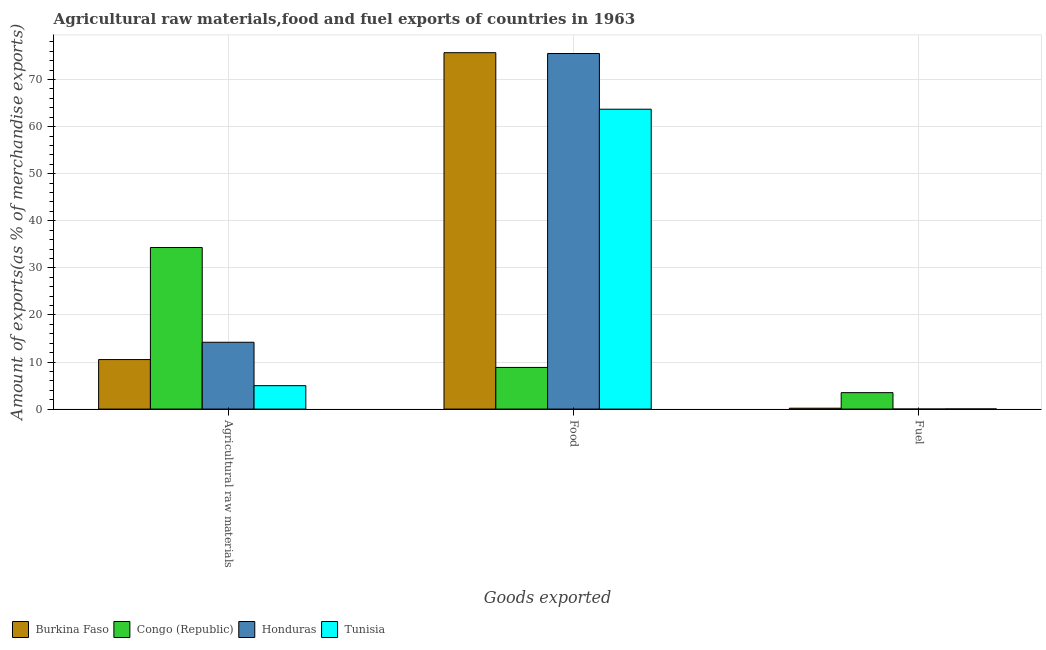How many different coloured bars are there?
Offer a terse response. 4. Are the number of bars on each tick of the X-axis equal?
Make the answer very short. Yes. How many bars are there on the 3rd tick from the right?
Provide a short and direct response. 4. What is the label of the 2nd group of bars from the left?
Your response must be concise. Food. What is the percentage of fuel exports in Congo (Republic)?
Offer a terse response. 3.49. Across all countries, what is the maximum percentage of food exports?
Make the answer very short. 75.71. Across all countries, what is the minimum percentage of fuel exports?
Keep it short and to the point. 1.2206406625286e-6. In which country was the percentage of fuel exports maximum?
Your answer should be compact. Congo (Republic). In which country was the percentage of fuel exports minimum?
Your answer should be very brief. Honduras. What is the total percentage of food exports in the graph?
Your answer should be very brief. 223.8. What is the difference between the percentage of food exports in Honduras and that in Congo (Republic)?
Ensure brevity in your answer.  66.69. What is the difference between the percentage of food exports in Honduras and the percentage of raw materials exports in Congo (Republic)?
Provide a succinct answer. 41.22. What is the average percentage of raw materials exports per country?
Provide a succinct answer. 16. What is the difference between the percentage of raw materials exports and percentage of food exports in Congo (Republic)?
Keep it short and to the point. 25.47. What is the ratio of the percentage of raw materials exports in Congo (Republic) to that in Tunisia?
Make the answer very short. 6.9. Is the percentage of raw materials exports in Congo (Republic) less than that in Honduras?
Your answer should be compact. No. Is the difference between the percentage of food exports in Honduras and Burkina Faso greater than the difference between the percentage of fuel exports in Honduras and Burkina Faso?
Give a very brief answer. Yes. What is the difference between the highest and the second highest percentage of fuel exports?
Offer a very short reply. 3.31. What is the difference between the highest and the lowest percentage of raw materials exports?
Ensure brevity in your answer.  29.35. In how many countries, is the percentage of raw materials exports greater than the average percentage of raw materials exports taken over all countries?
Your response must be concise. 1. What does the 1st bar from the left in Food represents?
Ensure brevity in your answer.  Burkina Faso. What does the 2nd bar from the right in Agricultural raw materials represents?
Make the answer very short. Honduras. Is it the case that in every country, the sum of the percentage of raw materials exports and percentage of food exports is greater than the percentage of fuel exports?
Provide a short and direct response. Yes. How many bars are there?
Offer a terse response. 12. What is the difference between two consecutive major ticks on the Y-axis?
Your answer should be very brief. 10. Are the values on the major ticks of Y-axis written in scientific E-notation?
Your response must be concise. No. Does the graph contain any zero values?
Your answer should be very brief. No. Does the graph contain grids?
Ensure brevity in your answer.  Yes. Where does the legend appear in the graph?
Make the answer very short. Bottom left. What is the title of the graph?
Provide a succinct answer. Agricultural raw materials,food and fuel exports of countries in 1963. What is the label or title of the X-axis?
Your answer should be compact. Goods exported. What is the label or title of the Y-axis?
Give a very brief answer. Amount of exports(as % of merchandise exports). What is the Amount of exports(as % of merchandise exports) in Burkina Faso in Agricultural raw materials?
Ensure brevity in your answer.  10.52. What is the Amount of exports(as % of merchandise exports) of Congo (Republic) in Agricultural raw materials?
Give a very brief answer. 34.32. What is the Amount of exports(as % of merchandise exports) of Honduras in Agricultural raw materials?
Make the answer very short. 14.2. What is the Amount of exports(as % of merchandise exports) in Tunisia in Agricultural raw materials?
Provide a short and direct response. 4.98. What is the Amount of exports(as % of merchandise exports) of Burkina Faso in Food?
Keep it short and to the point. 75.71. What is the Amount of exports(as % of merchandise exports) in Congo (Republic) in Food?
Give a very brief answer. 8.85. What is the Amount of exports(as % of merchandise exports) in Honduras in Food?
Keep it short and to the point. 75.54. What is the Amount of exports(as % of merchandise exports) of Tunisia in Food?
Make the answer very short. 63.7. What is the Amount of exports(as % of merchandise exports) in Burkina Faso in Fuel?
Keep it short and to the point. 0.19. What is the Amount of exports(as % of merchandise exports) of Congo (Republic) in Fuel?
Your answer should be compact. 3.49. What is the Amount of exports(as % of merchandise exports) of Honduras in Fuel?
Offer a terse response. 1.2206406625286e-6. What is the Amount of exports(as % of merchandise exports) in Tunisia in Fuel?
Your answer should be compact. 0.03. Across all Goods exported, what is the maximum Amount of exports(as % of merchandise exports) in Burkina Faso?
Your response must be concise. 75.71. Across all Goods exported, what is the maximum Amount of exports(as % of merchandise exports) of Congo (Republic)?
Your answer should be compact. 34.32. Across all Goods exported, what is the maximum Amount of exports(as % of merchandise exports) in Honduras?
Provide a short and direct response. 75.54. Across all Goods exported, what is the maximum Amount of exports(as % of merchandise exports) in Tunisia?
Offer a terse response. 63.7. Across all Goods exported, what is the minimum Amount of exports(as % of merchandise exports) in Burkina Faso?
Your answer should be compact. 0.19. Across all Goods exported, what is the minimum Amount of exports(as % of merchandise exports) in Congo (Republic)?
Make the answer very short. 3.49. Across all Goods exported, what is the minimum Amount of exports(as % of merchandise exports) of Honduras?
Your answer should be compact. 1.2206406625286e-6. Across all Goods exported, what is the minimum Amount of exports(as % of merchandise exports) in Tunisia?
Provide a short and direct response. 0.03. What is the total Amount of exports(as % of merchandise exports) of Burkina Faso in the graph?
Your response must be concise. 86.41. What is the total Amount of exports(as % of merchandise exports) of Congo (Republic) in the graph?
Provide a short and direct response. 46.66. What is the total Amount of exports(as % of merchandise exports) of Honduras in the graph?
Ensure brevity in your answer.  89.74. What is the total Amount of exports(as % of merchandise exports) in Tunisia in the graph?
Your response must be concise. 68.71. What is the difference between the Amount of exports(as % of merchandise exports) of Burkina Faso in Agricultural raw materials and that in Food?
Your answer should be very brief. -65.2. What is the difference between the Amount of exports(as % of merchandise exports) of Congo (Republic) in Agricultural raw materials and that in Food?
Make the answer very short. 25.47. What is the difference between the Amount of exports(as % of merchandise exports) of Honduras in Agricultural raw materials and that in Food?
Your answer should be compact. -61.34. What is the difference between the Amount of exports(as % of merchandise exports) of Tunisia in Agricultural raw materials and that in Food?
Offer a terse response. -58.73. What is the difference between the Amount of exports(as % of merchandise exports) of Burkina Faso in Agricultural raw materials and that in Fuel?
Provide a short and direct response. 10.33. What is the difference between the Amount of exports(as % of merchandise exports) of Congo (Republic) in Agricultural raw materials and that in Fuel?
Ensure brevity in your answer.  30.83. What is the difference between the Amount of exports(as % of merchandise exports) in Honduras in Agricultural raw materials and that in Fuel?
Offer a terse response. 14.2. What is the difference between the Amount of exports(as % of merchandise exports) of Tunisia in Agricultural raw materials and that in Fuel?
Offer a very short reply. 4.95. What is the difference between the Amount of exports(as % of merchandise exports) of Burkina Faso in Food and that in Fuel?
Ensure brevity in your answer.  75.53. What is the difference between the Amount of exports(as % of merchandise exports) in Congo (Republic) in Food and that in Fuel?
Keep it short and to the point. 5.36. What is the difference between the Amount of exports(as % of merchandise exports) of Honduras in Food and that in Fuel?
Provide a succinct answer. 75.54. What is the difference between the Amount of exports(as % of merchandise exports) in Tunisia in Food and that in Fuel?
Your response must be concise. 63.68. What is the difference between the Amount of exports(as % of merchandise exports) in Burkina Faso in Agricultural raw materials and the Amount of exports(as % of merchandise exports) in Congo (Republic) in Food?
Offer a very short reply. 1.67. What is the difference between the Amount of exports(as % of merchandise exports) in Burkina Faso in Agricultural raw materials and the Amount of exports(as % of merchandise exports) in Honduras in Food?
Give a very brief answer. -65.02. What is the difference between the Amount of exports(as % of merchandise exports) of Burkina Faso in Agricultural raw materials and the Amount of exports(as % of merchandise exports) of Tunisia in Food?
Give a very brief answer. -53.19. What is the difference between the Amount of exports(as % of merchandise exports) in Congo (Republic) in Agricultural raw materials and the Amount of exports(as % of merchandise exports) in Honduras in Food?
Your answer should be compact. -41.22. What is the difference between the Amount of exports(as % of merchandise exports) of Congo (Republic) in Agricultural raw materials and the Amount of exports(as % of merchandise exports) of Tunisia in Food?
Offer a very short reply. -29.38. What is the difference between the Amount of exports(as % of merchandise exports) of Honduras in Agricultural raw materials and the Amount of exports(as % of merchandise exports) of Tunisia in Food?
Your response must be concise. -49.51. What is the difference between the Amount of exports(as % of merchandise exports) of Burkina Faso in Agricultural raw materials and the Amount of exports(as % of merchandise exports) of Congo (Republic) in Fuel?
Provide a succinct answer. 7.03. What is the difference between the Amount of exports(as % of merchandise exports) in Burkina Faso in Agricultural raw materials and the Amount of exports(as % of merchandise exports) in Honduras in Fuel?
Offer a very short reply. 10.52. What is the difference between the Amount of exports(as % of merchandise exports) of Burkina Faso in Agricultural raw materials and the Amount of exports(as % of merchandise exports) of Tunisia in Fuel?
Offer a terse response. 10.49. What is the difference between the Amount of exports(as % of merchandise exports) of Congo (Republic) in Agricultural raw materials and the Amount of exports(as % of merchandise exports) of Honduras in Fuel?
Your response must be concise. 34.32. What is the difference between the Amount of exports(as % of merchandise exports) of Congo (Republic) in Agricultural raw materials and the Amount of exports(as % of merchandise exports) of Tunisia in Fuel?
Your answer should be very brief. 34.29. What is the difference between the Amount of exports(as % of merchandise exports) of Honduras in Agricultural raw materials and the Amount of exports(as % of merchandise exports) of Tunisia in Fuel?
Your response must be concise. 14.17. What is the difference between the Amount of exports(as % of merchandise exports) in Burkina Faso in Food and the Amount of exports(as % of merchandise exports) in Congo (Republic) in Fuel?
Make the answer very short. 72.22. What is the difference between the Amount of exports(as % of merchandise exports) of Burkina Faso in Food and the Amount of exports(as % of merchandise exports) of Honduras in Fuel?
Offer a very short reply. 75.71. What is the difference between the Amount of exports(as % of merchandise exports) of Burkina Faso in Food and the Amount of exports(as % of merchandise exports) of Tunisia in Fuel?
Your response must be concise. 75.68. What is the difference between the Amount of exports(as % of merchandise exports) in Congo (Republic) in Food and the Amount of exports(as % of merchandise exports) in Honduras in Fuel?
Make the answer very short. 8.85. What is the difference between the Amount of exports(as % of merchandise exports) of Congo (Republic) in Food and the Amount of exports(as % of merchandise exports) of Tunisia in Fuel?
Give a very brief answer. 8.82. What is the difference between the Amount of exports(as % of merchandise exports) of Honduras in Food and the Amount of exports(as % of merchandise exports) of Tunisia in Fuel?
Ensure brevity in your answer.  75.51. What is the average Amount of exports(as % of merchandise exports) of Burkina Faso per Goods exported?
Provide a short and direct response. 28.8. What is the average Amount of exports(as % of merchandise exports) in Congo (Republic) per Goods exported?
Give a very brief answer. 15.55. What is the average Amount of exports(as % of merchandise exports) of Honduras per Goods exported?
Provide a succinct answer. 29.91. What is the average Amount of exports(as % of merchandise exports) in Tunisia per Goods exported?
Your response must be concise. 22.9. What is the difference between the Amount of exports(as % of merchandise exports) of Burkina Faso and Amount of exports(as % of merchandise exports) of Congo (Republic) in Agricultural raw materials?
Your answer should be compact. -23.8. What is the difference between the Amount of exports(as % of merchandise exports) in Burkina Faso and Amount of exports(as % of merchandise exports) in Honduras in Agricultural raw materials?
Your response must be concise. -3.68. What is the difference between the Amount of exports(as % of merchandise exports) in Burkina Faso and Amount of exports(as % of merchandise exports) in Tunisia in Agricultural raw materials?
Keep it short and to the point. 5.54. What is the difference between the Amount of exports(as % of merchandise exports) in Congo (Republic) and Amount of exports(as % of merchandise exports) in Honduras in Agricultural raw materials?
Your answer should be compact. 20.12. What is the difference between the Amount of exports(as % of merchandise exports) of Congo (Republic) and Amount of exports(as % of merchandise exports) of Tunisia in Agricultural raw materials?
Offer a terse response. 29.35. What is the difference between the Amount of exports(as % of merchandise exports) of Honduras and Amount of exports(as % of merchandise exports) of Tunisia in Agricultural raw materials?
Your answer should be compact. 9.22. What is the difference between the Amount of exports(as % of merchandise exports) in Burkina Faso and Amount of exports(as % of merchandise exports) in Congo (Republic) in Food?
Offer a terse response. 66.87. What is the difference between the Amount of exports(as % of merchandise exports) in Burkina Faso and Amount of exports(as % of merchandise exports) in Honduras in Food?
Your answer should be compact. 0.17. What is the difference between the Amount of exports(as % of merchandise exports) of Burkina Faso and Amount of exports(as % of merchandise exports) of Tunisia in Food?
Provide a short and direct response. 12.01. What is the difference between the Amount of exports(as % of merchandise exports) in Congo (Republic) and Amount of exports(as % of merchandise exports) in Honduras in Food?
Provide a short and direct response. -66.69. What is the difference between the Amount of exports(as % of merchandise exports) of Congo (Republic) and Amount of exports(as % of merchandise exports) of Tunisia in Food?
Your answer should be compact. -54.86. What is the difference between the Amount of exports(as % of merchandise exports) in Honduras and Amount of exports(as % of merchandise exports) in Tunisia in Food?
Offer a terse response. 11.84. What is the difference between the Amount of exports(as % of merchandise exports) in Burkina Faso and Amount of exports(as % of merchandise exports) in Congo (Republic) in Fuel?
Your answer should be very brief. -3.31. What is the difference between the Amount of exports(as % of merchandise exports) of Burkina Faso and Amount of exports(as % of merchandise exports) of Honduras in Fuel?
Provide a succinct answer. 0.19. What is the difference between the Amount of exports(as % of merchandise exports) of Burkina Faso and Amount of exports(as % of merchandise exports) of Tunisia in Fuel?
Your answer should be compact. 0.16. What is the difference between the Amount of exports(as % of merchandise exports) in Congo (Republic) and Amount of exports(as % of merchandise exports) in Honduras in Fuel?
Your answer should be compact. 3.49. What is the difference between the Amount of exports(as % of merchandise exports) in Congo (Republic) and Amount of exports(as % of merchandise exports) in Tunisia in Fuel?
Provide a succinct answer. 3.46. What is the difference between the Amount of exports(as % of merchandise exports) of Honduras and Amount of exports(as % of merchandise exports) of Tunisia in Fuel?
Offer a terse response. -0.03. What is the ratio of the Amount of exports(as % of merchandise exports) of Burkina Faso in Agricultural raw materials to that in Food?
Offer a terse response. 0.14. What is the ratio of the Amount of exports(as % of merchandise exports) of Congo (Republic) in Agricultural raw materials to that in Food?
Make the answer very short. 3.88. What is the ratio of the Amount of exports(as % of merchandise exports) of Honduras in Agricultural raw materials to that in Food?
Make the answer very short. 0.19. What is the ratio of the Amount of exports(as % of merchandise exports) of Tunisia in Agricultural raw materials to that in Food?
Your response must be concise. 0.08. What is the ratio of the Amount of exports(as % of merchandise exports) of Burkina Faso in Agricultural raw materials to that in Fuel?
Provide a short and direct response. 56.81. What is the ratio of the Amount of exports(as % of merchandise exports) of Congo (Republic) in Agricultural raw materials to that in Fuel?
Give a very brief answer. 9.83. What is the ratio of the Amount of exports(as % of merchandise exports) of Honduras in Agricultural raw materials to that in Fuel?
Keep it short and to the point. 1.16e+07. What is the ratio of the Amount of exports(as % of merchandise exports) of Tunisia in Agricultural raw materials to that in Fuel?
Keep it short and to the point. 178.42. What is the ratio of the Amount of exports(as % of merchandise exports) of Burkina Faso in Food to that in Fuel?
Your answer should be very brief. 408.99. What is the ratio of the Amount of exports(as % of merchandise exports) of Congo (Republic) in Food to that in Fuel?
Offer a very short reply. 2.53. What is the ratio of the Amount of exports(as % of merchandise exports) in Honduras in Food to that in Fuel?
Offer a very short reply. 6.19e+07. What is the ratio of the Amount of exports(as % of merchandise exports) of Tunisia in Food to that in Fuel?
Give a very brief answer. 2284.51. What is the difference between the highest and the second highest Amount of exports(as % of merchandise exports) of Burkina Faso?
Your answer should be compact. 65.2. What is the difference between the highest and the second highest Amount of exports(as % of merchandise exports) of Congo (Republic)?
Offer a very short reply. 25.47. What is the difference between the highest and the second highest Amount of exports(as % of merchandise exports) in Honduras?
Your answer should be compact. 61.34. What is the difference between the highest and the second highest Amount of exports(as % of merchandise exports) of Tunisia?
Ensure brevity in your answer.  58.73. What is the difference between the highest and the lowest Amount of exports(as % of merchandise exports) of Burkina Faso?
Make the answer very short. 75.53. What is the difference between the highest and the lowest Amount of exports(as % of merchandise exports) in Congo (Republic)?
Your response must be concise. 30.83. What is the difference between the highest and the lowest Amount of exports(as % of merchandise exports) of Honduras?
Ensure brevity in your answer.  75.54. What is the difference between the highest and the lowest Amount of exports(as % of merchandise exports) of Tunisia?
Keep it short and to the point. 63.68. 